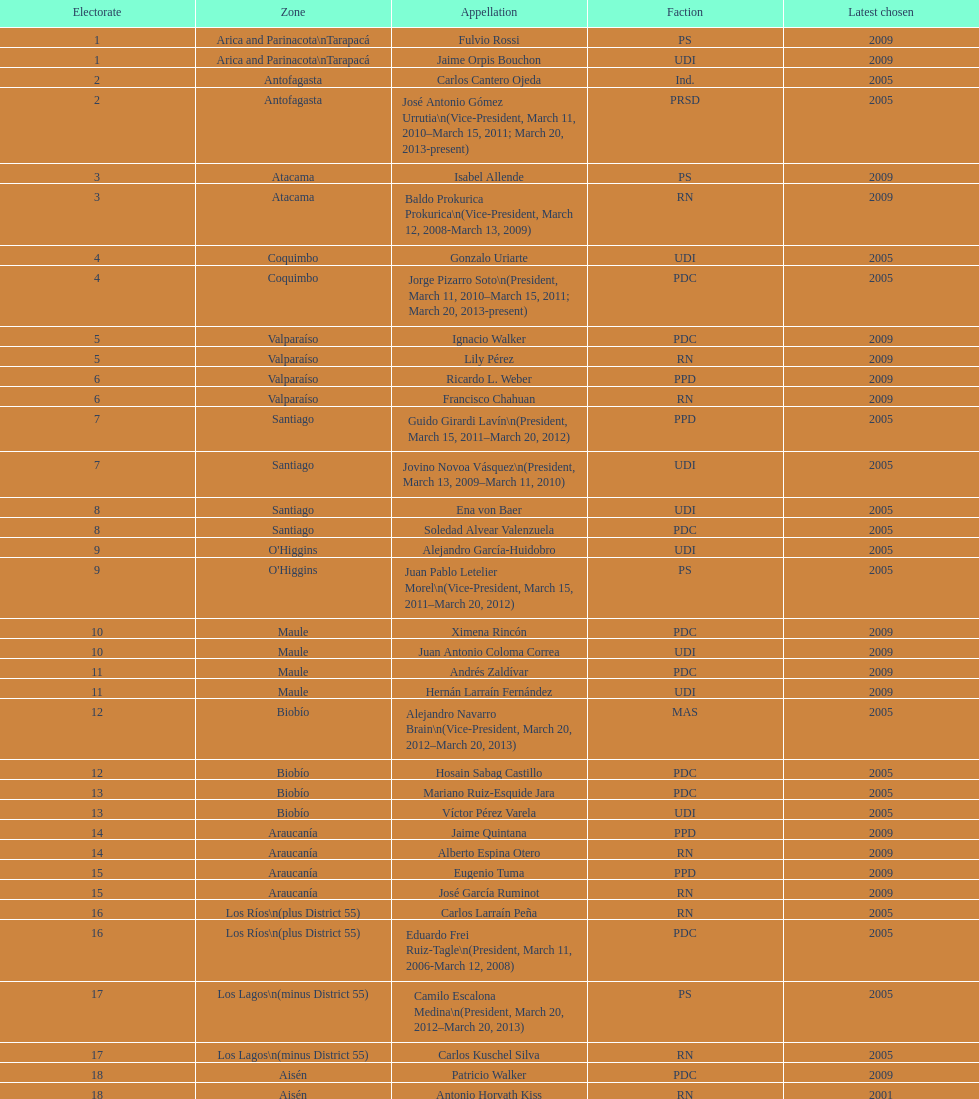Who was not last elected in either 2005 or 2009? Antonio Horvath Kiss. 